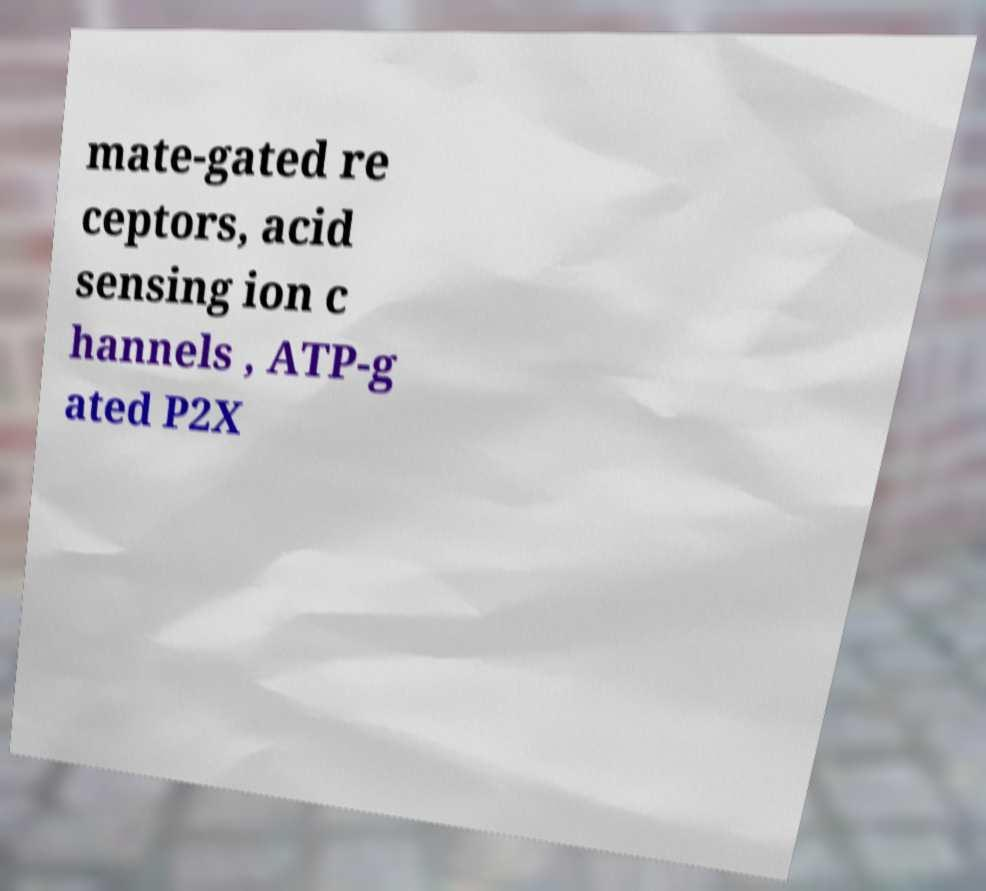Could you assist in decoding the text presented in this image and type it out clearly? mate-gated re ceptors, acid sensing ion c hannels , ATP-g ated P2X 